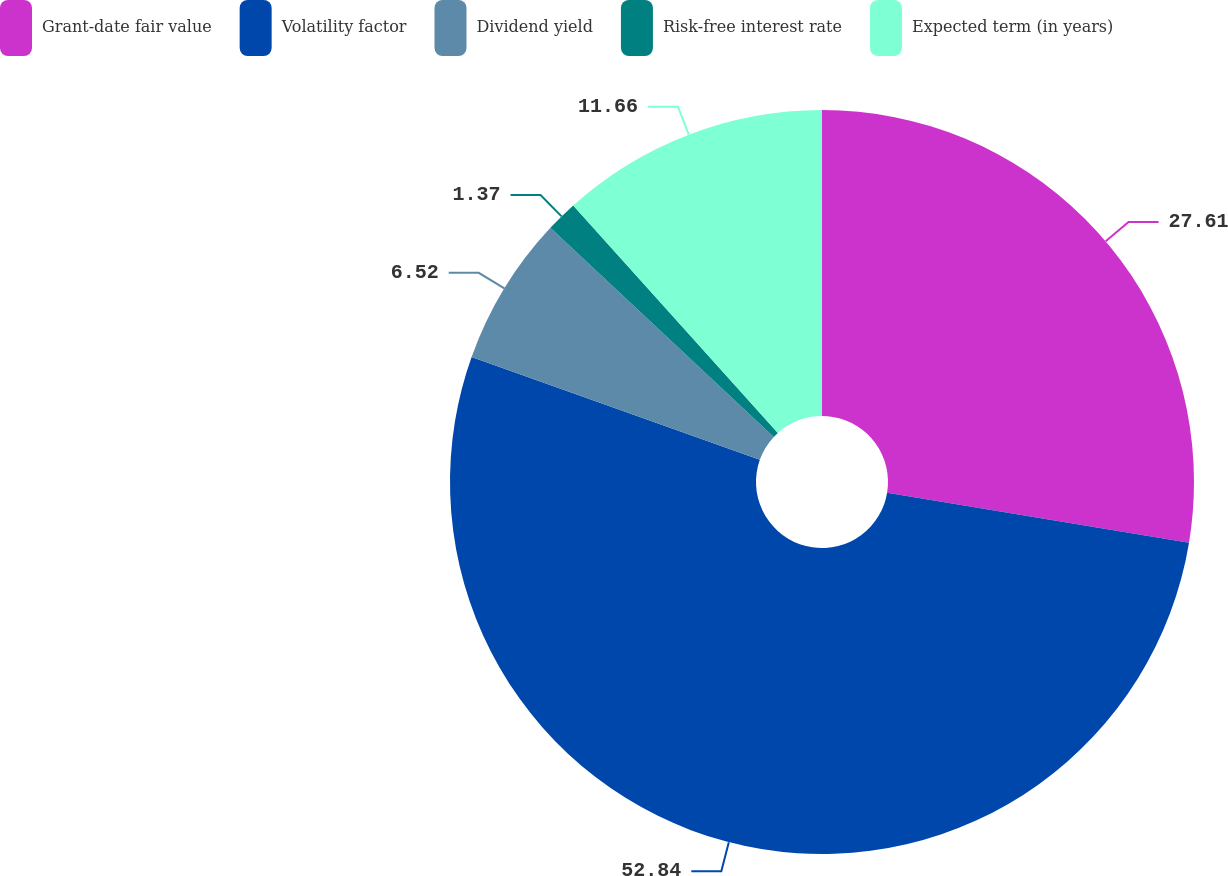Convert chart. <chart><loc_0><loc_0><loc_500><loc_500><pie_chart><fcel>Grant-date fair value<fcel>Volatility factor<fcel>Dividend yield<fcel>Risk-free interest rate<fcel>Expected term (in years)<nl><fcel>27.61%<fcel>52.85%<fcel>6.52%<fcel>1.37%<fcel>11.66%<nl></chart> 